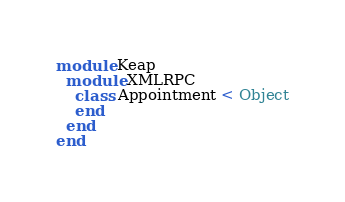<code> <loc_0><loc_0><loc_500><loc_500><_Ruby_>module Keap
  module XMLRPC
    class Appointment < Object
    end
  end
end
</code> 